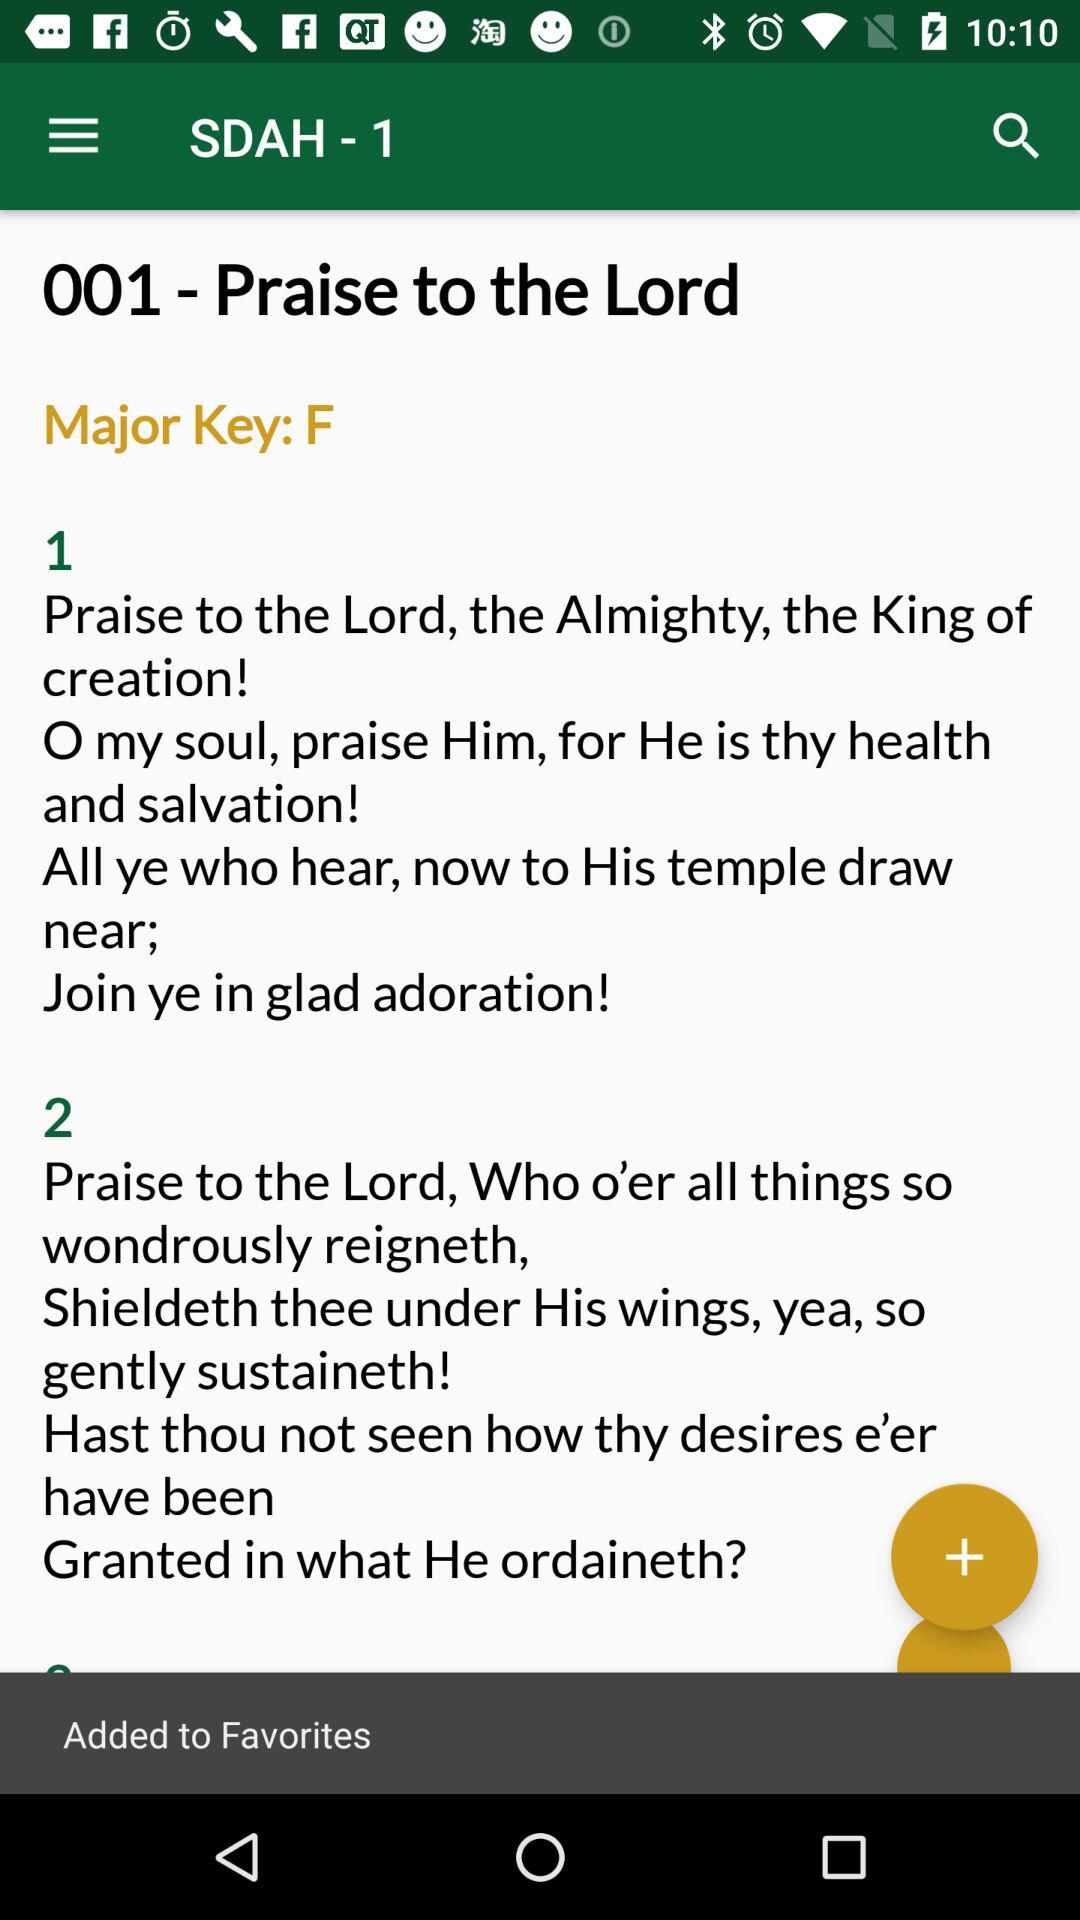What is the major key? The major key is "F". 